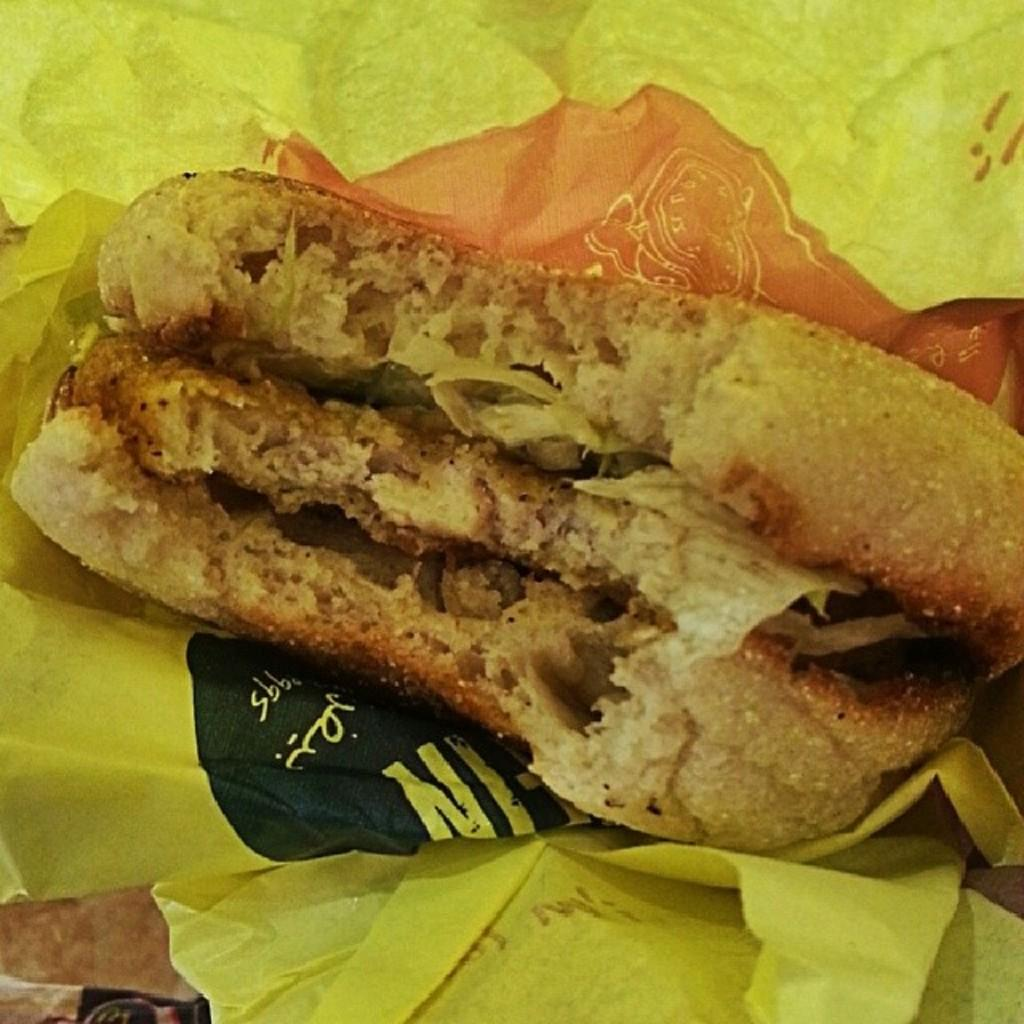What is the main subject in the center of the image? There is a yellow color paper in the center of the image. What is depicted on the yellow paper? There are food items depicted on the paper. Can you describe the object located at the bottom left side of the image? Unfortunately, the provided facts do not specify the nature of the object at the bottom left side of the image. How many cars are parked under the umbrella in the image? There are no cars or umbrellas present in the image. 